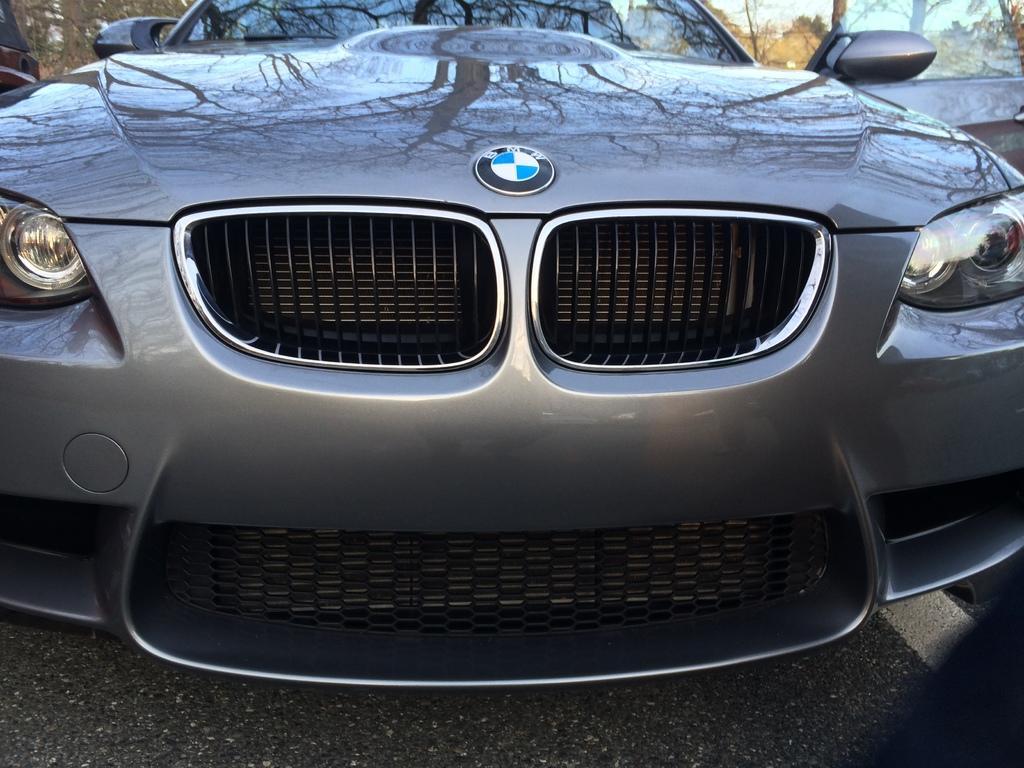Can you describe this image briefly? In this image there is a car. Only the front part of the car is captured in the image. There is a logo on the bonnet of the car. There is text above the logo. In the background there are trees. There are headlights to the car. At the bottom there is the road. 